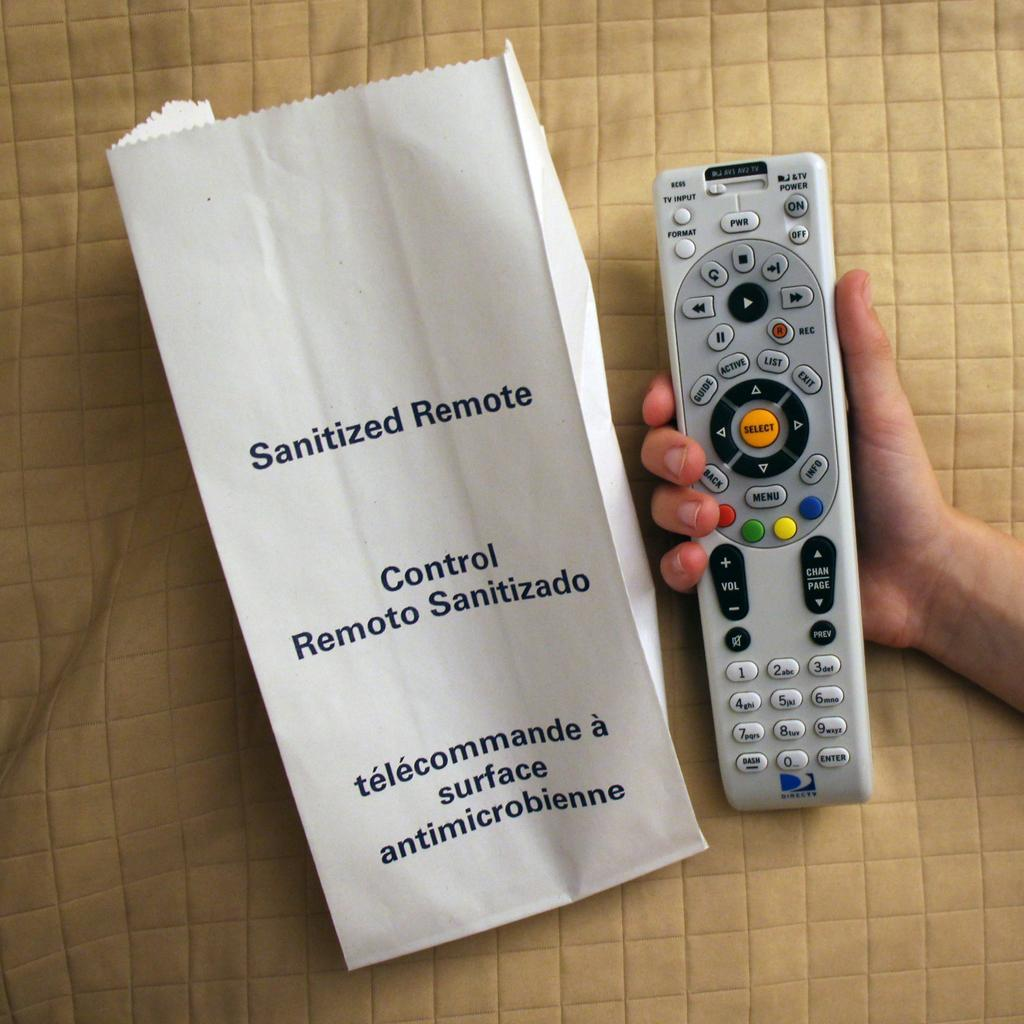Who is present in the image? There is a person in the image. What is the person holding in the image? The person is holding a remote. What objects are placed on a cloth in the image? There is a paper on a cloth in the image. What type of island can be seen in the background of the image? There is no island present in the image; it only features a person, a remote, a paper, and a cloth. 